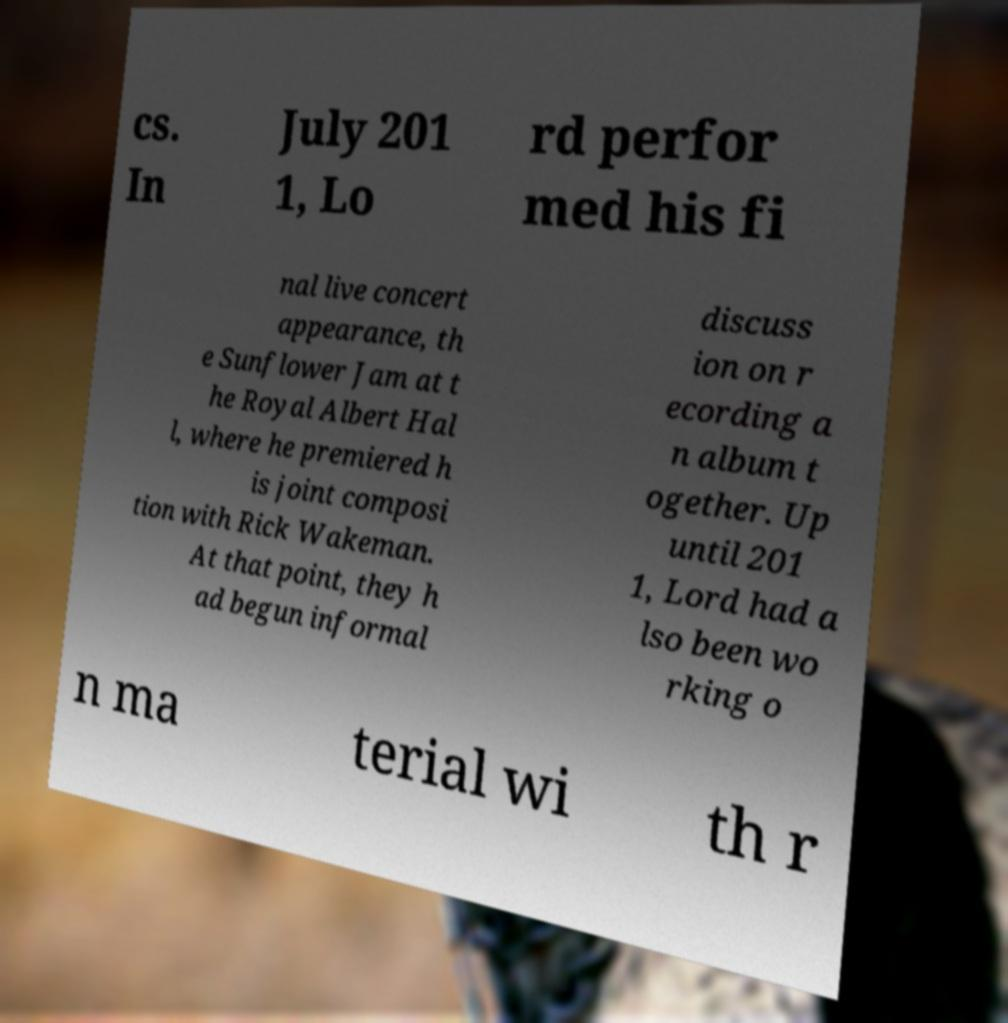Could you assist in decoding the text presented in this image and type it out clearly? cs. In July 201 1, Lo rd perfor med his fi nal live concert appearance, th e Sunflower Jam at t he Royal Albert Hal l, where he premiered h is joint composi tion with Rick Wakeman. At that point, they h ad begun informal discuss ion on r ecording a n album t ogether. Up until 201 1, Lord had a lso been wo rking o n ma terial wi th r 